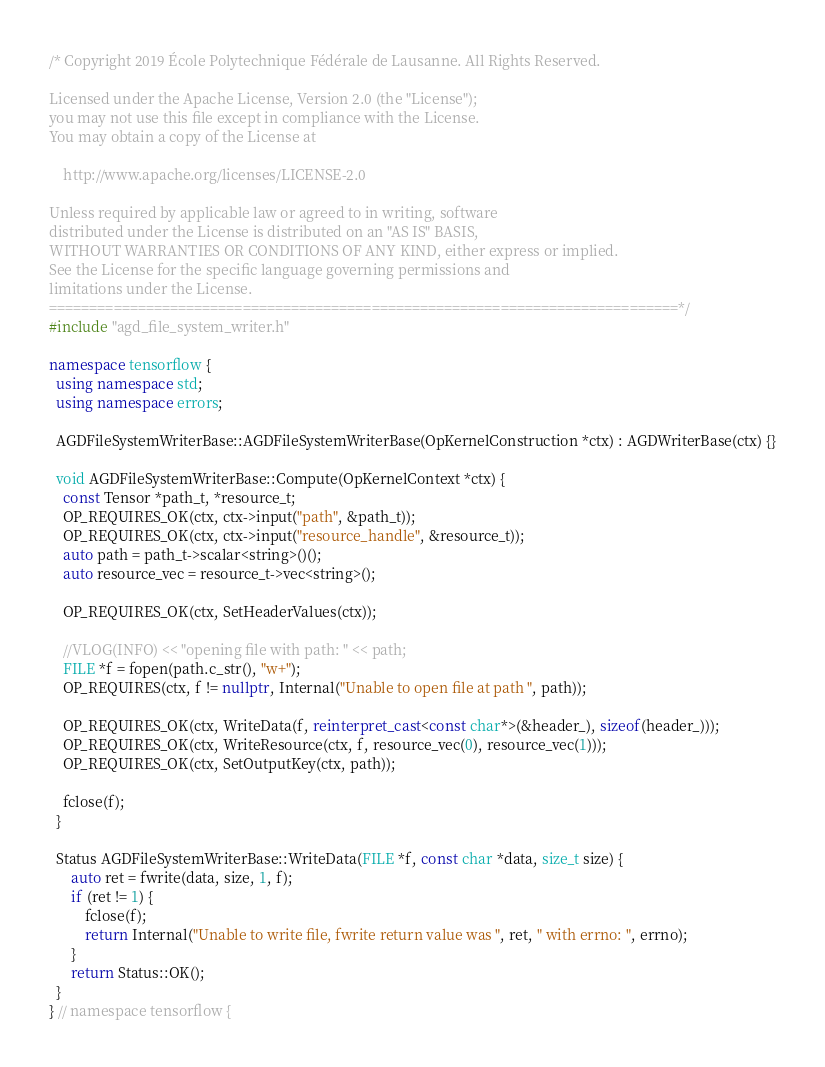Convert code to text. <code><loc_0><loc_0><loc_500><loc_500><_C++_>/* Copyright 2019 École Polytechnique Fédérale de Lausanne. All Rights Reserved.

Licensed under the Apache License, Version 2.0 (the "License");
you may not use this file except in compliance with the License.
You may obtain a copy of the License at

    http://www.apache.org/licenses/LICENSE-2.0

Unless required by applicable law or agreed to in writing, software
distributed under the License is distributed on an "AS IS" BASIS,
WITHOUT WARRANTIES OR CONDITIONS OF ANY KIND, either express or implied.
See the License for the specific language governing permissions and
limitations under the License.
==============================================================================*/
#include "agd_file_system_writer.h"

namespace tensorflow {
  using namespace std;
  using namespace errors;

  AGDFileSystemWriterBase::AGDFileSystemWriterBase(OpKernelConstruction *ctx) : AGDWriterBase(ctx) {}

  void AGDFileSystemWriterBase::Compute(OpKernelContext *ctx) {
    const Tensor *path_t, *resource_t;
    OP_REQUIRES_OK(ctx, ctx->input("path", &path_t));
    OP_REQUIRES_OK(ctx, ctx->input("resource_handle", &resource_t));
    auto path = path_t->scalar<string>()();
    auto resource_vec = resource_t->vec<string>();

    OP_REQUIRES_OK(ctx, SetHeaderValues(ctx));

    //VLOG(INFO) << "opening file with path: " << path;
    FILE *f = fopen(path.c_str(), "w+");
    OP_REQUIRES(ctx, f != nullptr, Internal("Unable to open file at path ", path));

    OP_REQUIRES_OK(ctx, WriteData(f, reinterpret_cast<const char*>(&header_), sizeof(header_)));
    OP_REQUIRES_OK(ctx, WriteResource(ctx, f, resource_vec(0), resource_vec(1)));
    OP_REQUIRES_OK(ctx, SetOutputKey(ctx, path));

    fclose(f);
  }

  Status AGDFileSystemWriterBase::WriteData(FILE *f, const char *data, size_t size) {
      auto ret = fwrite(data, size, 1, f);
      if (ret != 1) {
          fclose(f);
          return Internal("Unable to write file, fwrite return value was ", ret, " with errno: ", errno);
      }
      return Status::OK();
  }
} // namespace tensorflow {
</code> 